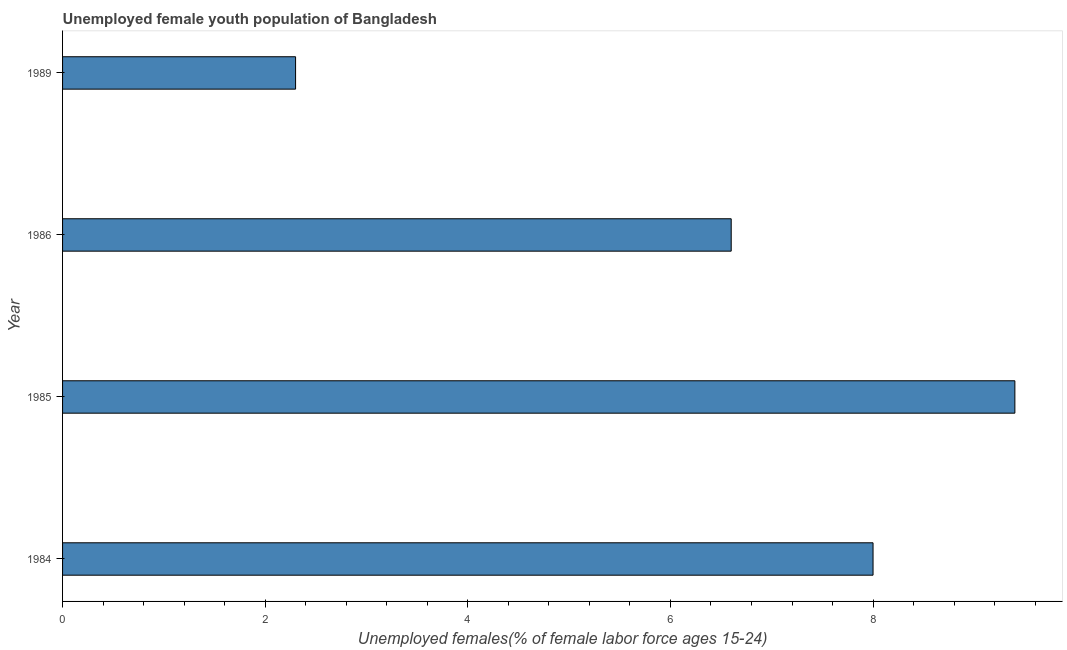Does the graph contain any zero values?
Make the answer very short. No. What is the title of the graph?
Make the answer very short. Unemployed female youth population of Bangladesh. What is the label or title of the X-axis?
Give a very brief answer. Unemployed females(% of female labor force ages 15-24). What is the label or title of the Y-axis?
Keep it short and to the point. Year. What is the unemployed female youth in 1985?
Ensure brevity in your answer.  9.4. Across all years, what is the maximum unemployed female youth?
Offer a very short reply. 9.4. Across all years, what is the minimum unemployed female youth?
Offer a terse response. 2.3. What is the sum of the unemployed female youth?
Your answer should be compact. 26.3. What is the average unemployed female youth per year?
Make the answer very short. 6.58. What is the median unemployed female youth?
Your answer should be compact. 7.3. What is the ratio of the unemployed female youth in 1985 to that in 1986?
Offer a very short reply. 1.42. In how many years, is the unemployed female youth greater than the average unemployed female youth taken over all years?
Ensure brevity in your answer.  3. What is the difference between two consecutive major ticks on the X-axis?
Your response must be concise. 2. What is the Unemployed females(% of female labor force ages 15-24) in 1985?
Ensure brevity in your answer.  9.4. What is the Unemployed females(% of female labor force ages 15-24) in 1986?
Ensure brevity in your answer.  6.6. What is the Unemployed females(% of female labor force ages 15-24) of 1989?
Your response must be concise. 2.3. What is the difference between the Unemployed females(% of female labor force ages 15-24) in 1984 and 1986?
Provide a short and direct response. 1.4. What is the difference between the Unemployed females(% of female labor force ages 15-24) in 1984 and 1989?
Offer a very short reply. 5.7. What is the difference between the Unemployed females(% of female labor force ages 15-24) in 1985 and 1989?
Keep it short and to the point. 7.1. What is the difference between the Unemployed females(% of female labor force ages 15-24) in 1986 and 1989?
Provide a succinct answer. 4.3. What is the ratio of the Unemployed females(% of female labor force ages 15-24) in 1984 to that in 1985?
Make the answer very short. 0.85. What is the ratio of the Unemployed females(% of female labor force ages 15-24) in 1984 to that in 1986?
Give a very brief answer. 1.21. What is the ratio of the Unemployed females(% of female labor force ages 15-24) in 1984 to that in 1989?
Provide a short and direct response. 3.48. What is the ratio of the Unemployed females(% of female labor force ages 15-24) in 1985 to that in 1986?
Offer a very short reply. 1.42. What is the ratio of the Unemployed females(% of female labor force ages 15-24) in 1985 to that in 1989?
Your response must be concise. 4.09. What is the ratio of the Unemployed females(% of female labor force ages 15-24) in 1986 to that in 1989?
Your answer should be very brief. 2.87. 